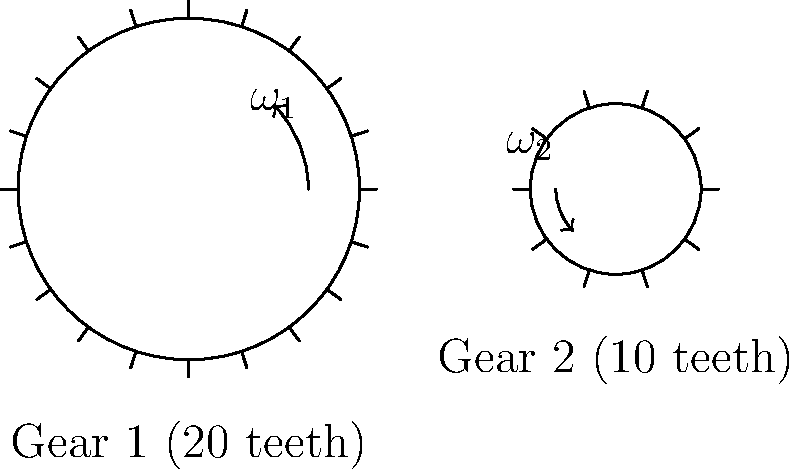In a vintage Italian film projector, two gears are meshed as shown in the diagram. Gear 1 has 20 teeth and rotates clockwise at an angular velocity of 30 rpm. Gear 2 has 10 teeth. Calculate the angular velocity of Gear 2 in rpm and determine its direction of rotation. To solve this problem, we'll follow these steps:

1. Understand the gear ratio:
   The gear ratio is determined by the number of teeth on each gear.
   Gear ratio = Number of teeth on driven gear / Number of teeth on driving gear
   Gear ratio = 10 / 20 = 1/2

2. Apply the principle of gear ratios:
   For meshed gears, the product of teeth and angular velocity is constant.
   $N_1 \omega_1 = N_2 \omega_2$
   Where $N$ is the number of teeth and $\omega$ is the angular velocity.

3. Substitute known values:
   $20 \times 30 = 10 \times \omega_2$

4. Solve for $\omega_2$:
   $\omega_2 = (20 \times 30) / 10 = 60$ rpm

5. Determine direction of rotation:
   When two gears mesh, they rotate in opposite directions.
   Since Gear 1 rotates clockwise, Gear 2 must rotate counterclockwise.

Therefore, Gear 2 rotates at 60 rpm in a counterclockwise direction.
Answer: 60 rpm counterclockwise 